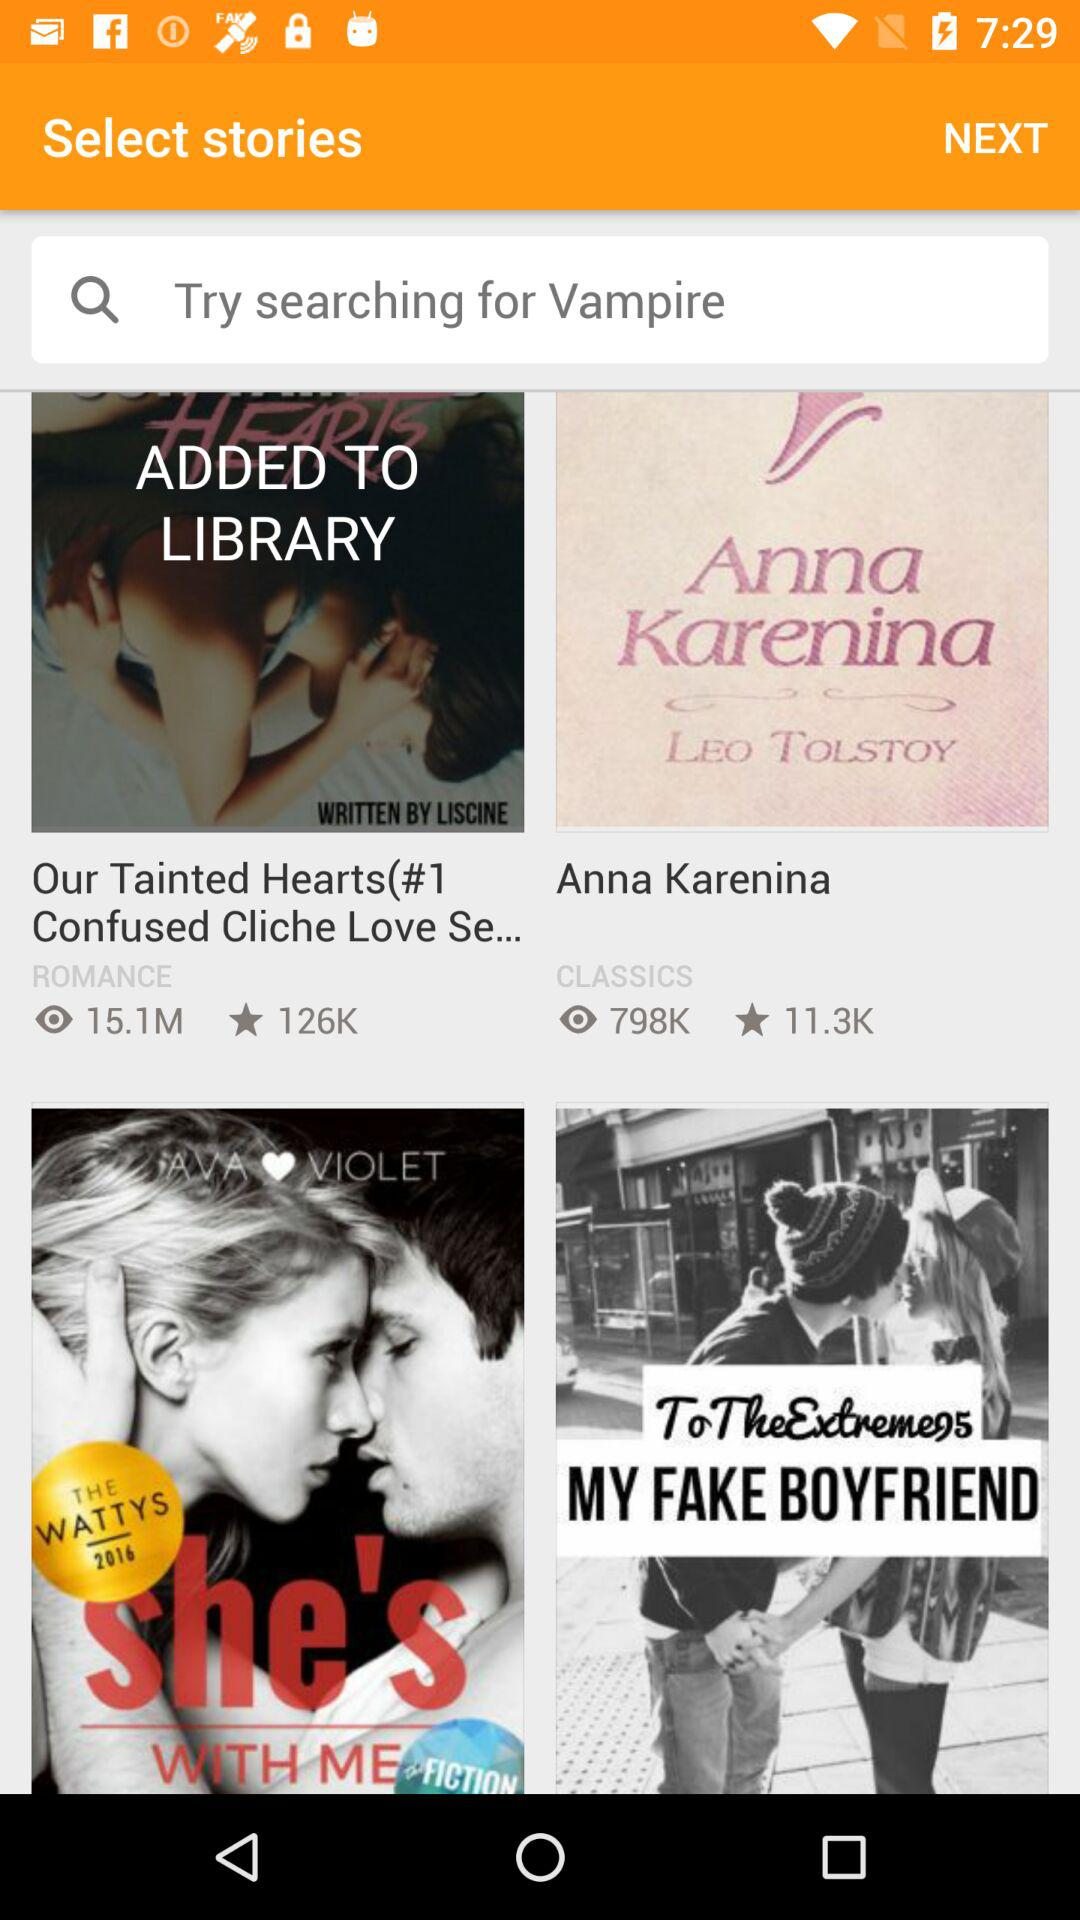What is the genre of the story "Our Tainted Hearts(#1 Confused Cliche Love Se..."? The genre of the story is "ROMANCE". 